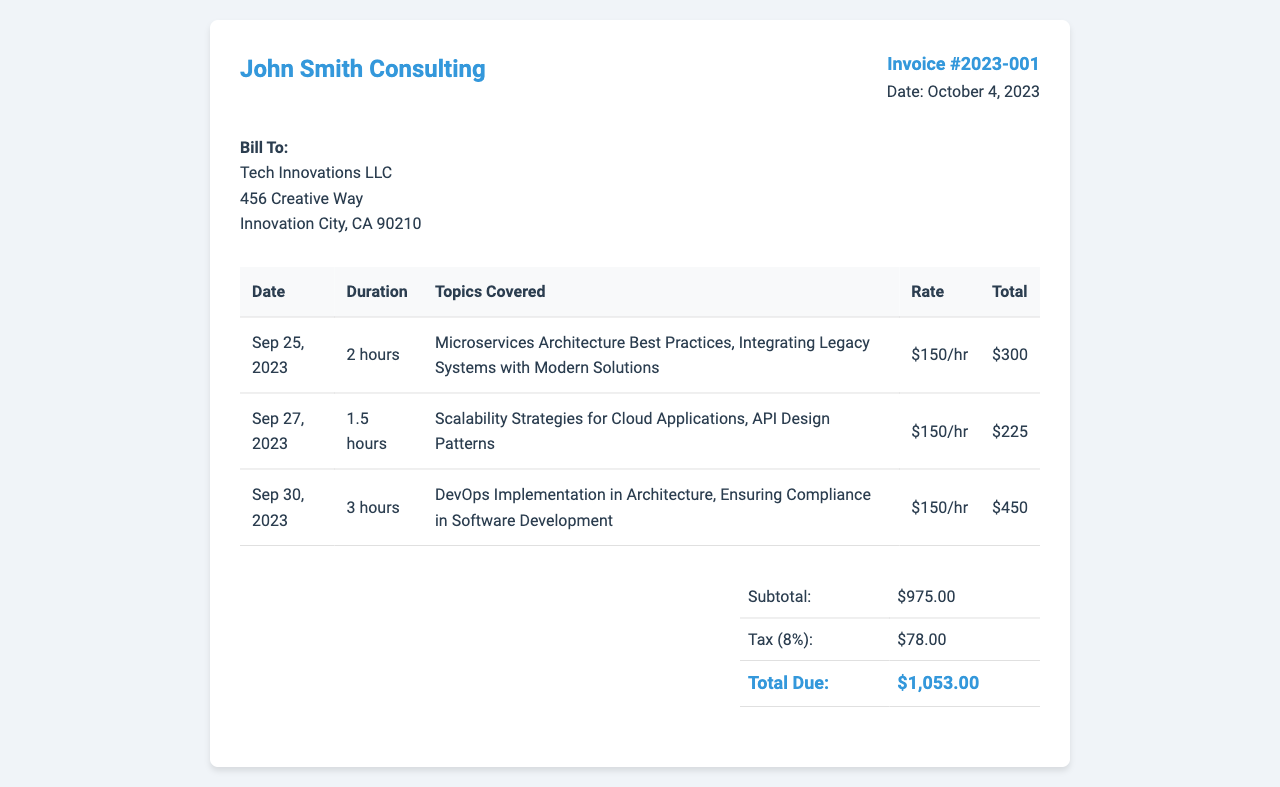what is the invoice number? The invoice number is clearly stated in the invoice details section.
Answer: Invoice #2023-001 what is the total due amount? The total due amount is presented in the total section of the invoice.
Answer: $1,053.00 how many hours were billed on September 27, 2023? The duration for the session on September 27, 2023, is listed in the detailed table.
Answer: 1.5 hours what was the rate charged per hour? The invoice specifies the rate charged for the consulting services in the table.
Answer: $150/hr what was covered in the session on September 30, 2023? The topics covered during the session are detailed in the corresponding table row.
Answer: DevOps Implementation in Architecture, Ensuring Compliance in Software Development what is the subtotal before tax? The subtotal is provided in the total section of the invoice prior to tax calculations.
Answer: $975.00 which company is billed on this invoice? The client's name is displayed in the client details section of the document.
Answer: Tech Innovations LLC what is the tax rate applied to the invoice? The tax rate is indicated in the total section of the invoice when calculating the total amount.
Answer: 8% 